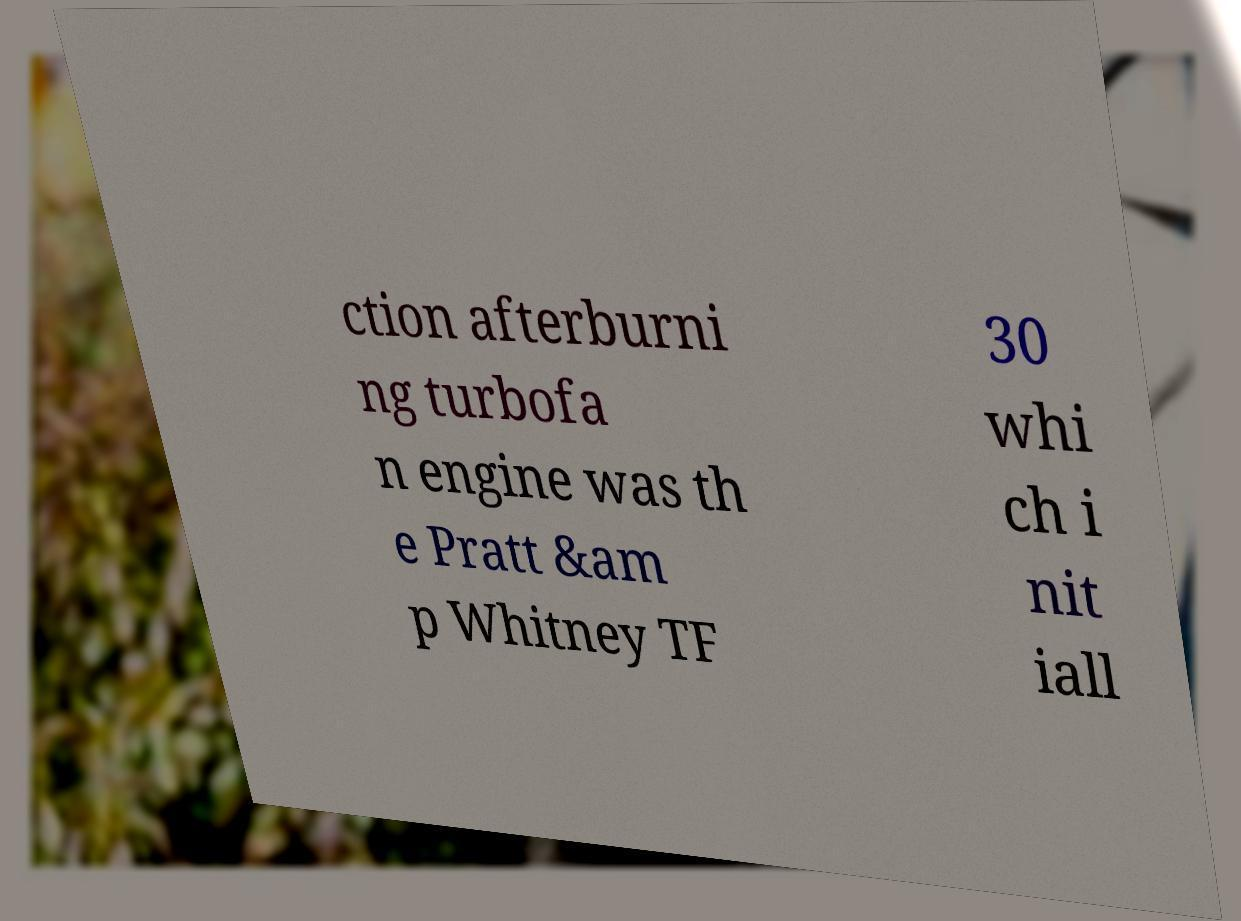I need the written content from this picture converted into text. Can you do that? ction afterburni ng turbofa n engine was th e Pratt &am p Whitney TF 30 whi ch i nit iall 